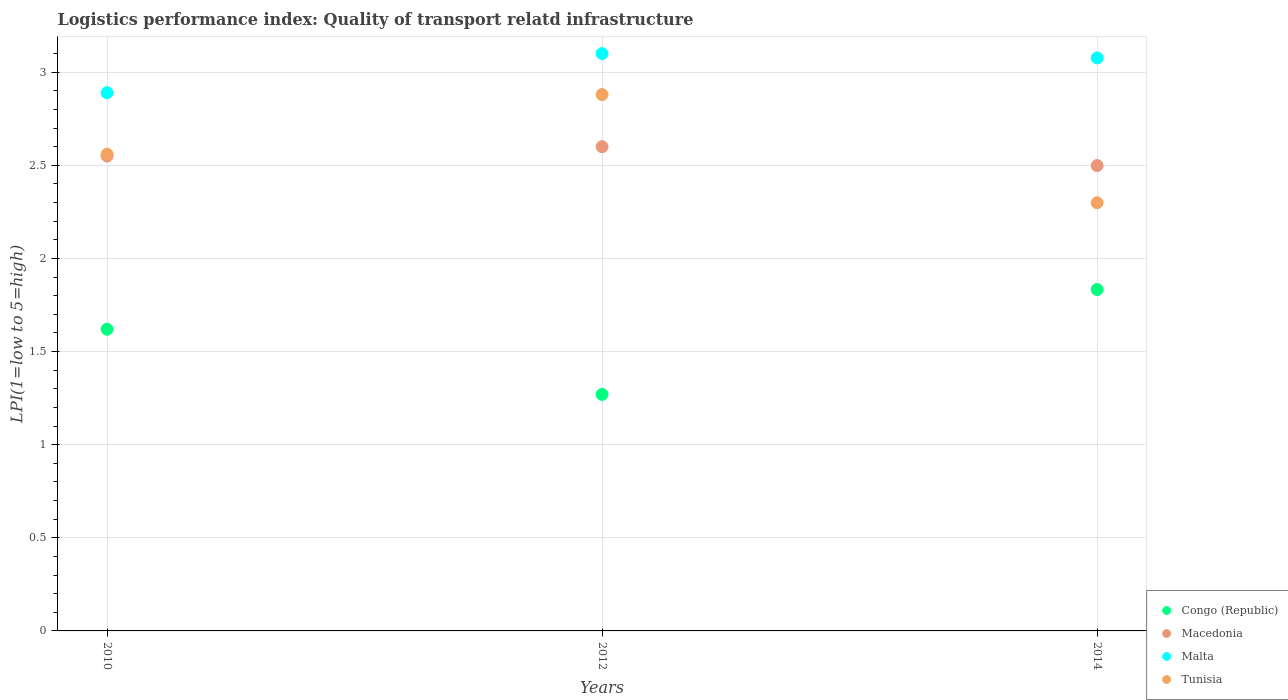What is the logistics performance index in Malta in 2012?
Ensure brevity in your answer.  3.1. Across all years, what is the maximum logistics performance index in Tunisia?
Offer a terse response. 2.88. Across all years, what is the minimum logistics performance index in Congo (Republic)?
Provide a short and direct response. 1.27. In which year was the logistics performance index in Congo (Republic) maximum?
Your answer should be very brief. 2014. What is the total logistics performance index in Tunisia in the graph?
Offer a very short reply. 7.74. What is the difference between the logistics performance index in Congo (Republic) in 2012 and that in 2014?
Give a very brief answer. -0.56. What is the difference between the logistics performance index in Tunisia in 2014 and the logistics performance index in Malta in 2010?
Provide a succinct answer. -0.59. What is the average logistics performance index in Malta per year?
Keep it short and to the point. 3.02. In the year 2010, what is the difference between the logistics performance index in Congo (Republic) and logistics performance index in Tunisia?
Your answer should be very brief. -0.94. In how many years, is the logistics performance index in Tunisia greater than 2?
Your response must be concise. 3. What is the ratio of the logistics performance index in Congo (Republic) in 2010 to that in 2014?
Offer a terse response. 0.88. What is the difference between the highest and the second highest logistics performance index in Macedonia?
Give a very brief answer. 0.05. What is the difference between the highest and the lowest logistics performance index in Congo (Republic)?
Provide a short and direct response. 0.56. Is it the case that in every year, the sum of the logistics performance index in Macedonia and logistics performance index in Tunisia  is greater than the sum of logistics performance index in Congo (Republic) and logistics performance index in Malta?
Your answer should be very brief. No. Does the logistics performance index in Macedonia monotonically increase over the years?
Provide a short and direct response. No. Is the logistics performance index in Malta strictly greater than the logistics performance index in Tunisia over the years?
Keep it short and to the point. Yes. How many dotlines are there?
Offer a terse response. 4. What is the difference between two consecutive major ticks on the Y-axis?
Keep it short and to the point. 0.5. Does the graph contain any zero values?
Provide a succinct answer. No. Does the graph contain grids?
Offer a very short reply. Yes. Where does the legend appear in the graph?
Keep it short and to the point. Bottom right. How many legend labels are there?
Your answer should be very brief. 4. How are the legend labels stacked?
Make the answer very short. Vertical. What is the title of the graph?
Provide a succinct answer. Logistics performance index: Quality of transport relatd infrastructure. Does "European Union" appear as one of the legend labels in the graph?
Provide a short and direct response. No. What is the label or title of the X-axis?
Make the answer very short. Years. What is the label or title of the Y-axis?
Your response must be concise. LPI(1=low to 5=high). What is the LPI(1=low to 5=high) in Congo (Republic) in 2010?
Your answer should be very brief. 1.62. What is the LPI(1=low to 5=high) of Macedonia in 2010?
Your answer should be very brief. 2.55. What is the LPI(1=low to 5=high) of Malta in 2010?
Ensure brevity in your answer.  2.89. What is the LPI(1=low to 5=high) in Tunisia in 2010?
Your answer should be very brief. 2.56. What is the LPI(1=low to 5=high) in Congo (Republic) in 2012?
Provide a succinct answer. 1.27. What is the LPI(1=low to 5=high) of Malta in 2012?
Make the answer very short. 3.1. What is the LPI(1=low to 5=high) in Tunisia in 2012?
Provide a short and direct response. 2.88. What is the LPI(1=low to 5=high) of Congo (Republic) in 2014?
Keep it short and to the point. 1.83. What is the LPI(1=low to 5=high) of Macedonia in 2014?
Give a very brief answer. 2.5. What is the LPI(1=low to 5=high) in Malta in 2014?
Provide a short and direct response. 3.08. What is the LPI(1=low to 5=high) of Tunisia in 2014?
Keep it short and to the point. 2.3. Across all years, what is the maximum LPI(1=low to 5=high) in Congo (Republic)?
Offer a terse response. 1.83. Across all years, what is the maximum LPI(1=low to 5=high) in Macedonia?
Offer a terse response. 2.6. Across all years, what is the maximum LPI(1=low to 5=high) in Malta?
Make the answer very short. 3.1. Across all years, what is the maximum LPI(1=low to 5=high) of Tunisia?
Ensure brevity in your answer.  2.88. Across all years, what is the minimum LPI(1=low to 5=high) of Congo (Republic)?
Make the answer very short. 1.27. Across all years, what is the minimum LPI(1=low to 5=high) of Macedonia?
Your answer should be very brief. 2.5. Across all years, what is the minimum LPI(1=low to 5=high) of Malta?
Make the answer very short. 2.89. Across all years, what is the minimum LPI(1=low to 5=high) in Tunisia?
Your response must be concise. 2.3. What is the total LPI(1=low to 5=high) of Congo (Republic) in the graph?
Your answer should be very brief. 4.72. What is the total LPI(1=low to 5=high) of Macedonia in the graph?
Ensure brevity in your answer.  7.65. What is the total LPI(1=low to 5=high) in Malta in the graph?
Ensure brevity in your answer.  9.07. What is the total LPI(1=low to 5=high) in Tunisia in the graph?
Ensure brevity in your answer.  7.74. What is the difference between the LPI(1=low to 5=high) of Congo (Republic) in 2010 and that in 2012?
Your response must be concise. 0.35. What is the difference between the LPI(1=low to 5=high) of Macedonia in 2010 and that in 2012?
Your response must be concise. -0.05. What is the difference between the LPI(1=low to 5=high) of Malta in 2010 and that in 2012?
Provide a succinct answer. -0.21. What is the difference between the LPI(1=low to 5=high) of Tunisia in 2010 and that in 2012?
Provide a succinct answer. -0.32. What is the difference between the LPI(1=low to 5=high) of Congo (Republic) in 2010 and that in 2014?
Your response must be concise. -0.21. What is the difference between the LPI(1=low to 5=high) in Macedonia in 2010 and that in 2014?
Ensure brevity in your answer.  0.05. What is the difference between the LPI(1=low to 5=high) in Malta in 2010 and that in 2014?
Provide a short and direct response. -0.19. What is the difference between the LPI(1=low to 5=high) in Tunisia in 2010 and that in 2014?
Give a very brief answer. 0.26. What is the difference between the LPI(1=low to 5=high) of Congo (Republic) in 2012 and that in 2014?
Provide a short and direct response. -0.56. What is the difference between the LPI(1=low to 5=high) in Macedonia in 2012 and that in 2014?
Make the answer very short. 0.1. What is the difference between the LPI(1=low to 5=high) in Malta in 2012 and that in 2014?
Your answer should be very brief. 0.02. What is the difference between the LPI(1=low to 5=high) of Tunisia in 2012 and that in 2014?
Provide a succinct answer. 0.58. What is the difference between the LPI(1=low to 5=high) in Congo (Republic) in 2010 and the LPI(1=low to 5=high) in Macedonia in 2012?
Provide a short and direct response. -0.98. What is the difference between the LPI(1=low to 5=high) of Congo (Republic) in 2010 and the LPI(1=low to 5=high) of Malta in 2012?
Offer a very short reply. -1.48. What is the difference between the LPI(1=low to 5=high) in Congo (Republic) in 2010 and the LPI(1=low to 5=high) in Tunisia in 2012?
Offer a very short reply. -1.26. What is the difference between the LPI(1=low to 5=high) in Macedonia in 2010 and the LPI(1=low to 5=high) in Malta in 2012?
Your answer should be compact. -0.55. What is the difference between the LPI(1=low to 5=high) of Macedonia in 2010 and the LPI(1=low to 5=high) of Tunisia in 2012?
Provide a succinct answer. -0.33. What is the difference between the LPI(1=low to 5=high) of Congo (Republic) in 2010 and the LPI(1=low to 5=high) of Macedonia in 2014?
Your response must be concise. -0.88. What is the difference between the LPI(1=low to 5=high) in Congo (Republic) in 2010 and the LPI(1=low to 5=high) in Malta in 2014?
Your answer should be compact. -1.46. What is the difference between the LPI(1=low to 5=high) in Congo (Republic) in 2010 and the LPI(1=low to 5=high) in Tunisia in 2014?
Offer a terse response. -0.68. What is the difference between the LPI(1=low to 5=high) of Macedonia in 2010 and the LPI(1=low to 5=high) of Malta in 2014?
Your answer should be very brief. -0.53. What is the difference between the LPI(1=low to 5=high) of Macedonia in 2010 and the LPI(1=low to 5=high) of Tunisia in 2014?
Keep it short and to the point. 0.25. What is the difference between the LPI(1=low to 5=high) in Malta in 2010 and the LPI(1=low to 5=high) in Tunisia in 2014?
Your response must be concise. 0.59. What is the difference between the LPI(1=low to 5=high) in Congo (Republic) in 2012 and the LPI(1=low to 5=high) in Macedonia in 2014?
Provide a succinct answer. -1.23. What is the difference between the LPI(1=low to 5=high) of Congo (Republic) in 2012 and the LPI(1=low to 5=high) of Malta in 2014?
Offer a very short reply. -1.81. What is the difference between the LPI(1=low to 5=high) in Congo (Republic) in 2012 and the LPI(1=low to 5=high) in Tunisia in 2014?
Give a very brief answer. -1.03. What is the difference between the LPI(1=low to 5=high) of Macedonia in 2012 and the LPI(1=low to 5=high) of Malta in 2014?
Your response must be concise. -0.48. What is the difference between the LPI(1=low to 5=high) of Macedonia in 2012 and the LPI(1=low to 5=high) of Tunisia in 2014?
Your answer should be very brief. 0.3. What is the difference between the LPI(1=low to 5=high) in Malta in 2012 and the LPI(1=low to 5=high) in Tunisia in 2014?
Offer a very short reply. 0.8. What is the average LPI(1=low to 5=high) of Congo (Republic) per year?
Provide a succinct answer. 1.57. What is the average LPI(1=low to 5=high) of Macedonia per year?
Your response must be concise. 2.55. What is the average LPI(1=low to 5=high) in Malta per year?
Make the answer very short. 3.02. What is the average LPI(1=low to 5=high) of Tunisia per year?
Provide a short and direct response. 2.58. In the year 2010, what is the difference between the LPI(1=low to 5=high) of Congo (Republic) and LPI(1=low to 5=high) of Macedonia?
Provide a short and direct response. -0.93. In the year 2010, what is the difference between the LPI(1=low to 5=high) in Congo (Republic) and LPI(1=low to 5=high) in Malta?
Your response must be concise. -1.27. In the year 2010, what is the difference between the LPI(1=low to 5=high) in Congo (Republic) and LPI(1=low to 5=high) in Tunisia?
Your answer should be compact. -0.94. In the year 2010, what is the difference between the LPI(1=low to 5=high) of Macedonia and LPI(1=low to 5=high) of Malta?
Keep it short and to the point. -0.34. In the year 2010, what is the difference between the LPI(1=low to 5=high) of Macedonia and LPI(1=low to 5=high) of Tunisia?
Provide a short and direct response. -0.01. In the year 2010, what is the difference between the LPI(1=low to 5=high) in Malta and LPI(1=low to 5=high) in Tunisia?
Your answer should be compact. 0.33. In the year 2012, what is the difference between the LPI(1=low to 5=high) of Congo (Republic) and LPI(1=low to 5=high) of Macedonia?
Keep it short and to the point. -1.33. In the year 2012, what is the difference between the LPI(1=low to 5=high) in Congo (Republic) and LPI(1=low to 5=high) in Malta?
Give a very brief answer. -1.83. In the year 2012, what is the difference between the LPI(1=low to 5=high) of Congo (Republic) and LPI(1=low to 5=high) of Tunisia?
Offer a very short reply. -1.61. In the year 2012, what is the difference between the LPI(1=low to 5=high) in Macedonia and LPI(1=low to 5=high) in Tunisia?
Keep it short and to the point. -0.28. In the year 2012, what is the difference between the LPI(1=low to 5=high) of Malta and LPI(1=low to 5=high) of Tunisia?
Offer a very short reply. 0.22. In the year 2014, what is the difference between the LPI(1=low to 5=high) of Congo (Republic) and LPI(1=low to 5=high) of Macedonia?
Offer a terse response. -0.67. In the year 2014, what is the difference between the LPI(1=low to 5=high) of Congo (Republic) and LPI(1=low to 5=high) of Malta?
Provide a succinct answer. -1.24. In the year 2014, what is the difference between the LPI(1=low to 5=high) in Congo (Republic) and LPI(1=low to 5=high) in Tunisia?
Provide a short and direct response. -0.47. In the year 2014, what is the difference between the LPI(1=low to 5=high) of Macedonia and LPI(1=low to 5=high) of Malta?
Keep it short and to the point. -0.58. In the year 2014, what is the difference between the LPI(1=low to 5=high) in Macedonia and LPI(1=low to 5=high) in Tunisia?
Make the answer very short. 0.2. In the year 2014, what is the difference between the LPI(1=low to 5=high) in Malta and LPI(1=low to 5=high) in Tunisia?
Make the answer very short. 0.78. What is the ratio of the LPI(1=low to 5=high) of Congo (Republic) in 2010 to that in 2012?
Offer a terse response. 1.28. What is the ratio of the LPI(1=low to 5=high) in Macedonia in 2010 to that in 2012?
Your answer should be very brief. 0.98. What is the ratio of the LPI(1=low to 5=high) in Malta in 2010 to that in 2012?
Provide a succinct answer. 0.93. What is the ratio of the LPI(1=low to 5=high) in Tunisia in 2010 to that in 2012?
Offer a terse response. 0.89. What is the ratio of the LPI(1=low to 5=high) in Congo (Republic) in 2010 to that in 2014?
Keep it short and to the point. 0.88. What is the ratio of the LPI(1=low to 5=high) of Macedonia in 2010 to that in 2014?
Your response must be concise. 1.02. What is the ratio of the LPI(1=low to 5=high) in Malta in 2010 to that in 2014?
Provide a succinct answer. 0.94. What is the ratio of the LPI(1=low to 5=high) of Tunisia in 2010 to that in 2014?
Your response must be concise. 1.11. What is the ratio of the LPI(1=low to 5=high) of Congo (Republic) in 2012 to that in 2014?
Your answer should be very brief. 0.69. What is the ratio of the LPI(1=low to 5=high) in Macedonia in 2012 to that in 2014?
Give a very brief answer. 1.04. What is the ratio of the LPI(1=low to 5=high) of Malta in 2012 to that in 2014?
Give a very brief answer. 1.01. What is the ratio of the LPI(1=low to 5=high) of Tunisia in 2012 to that in 2014?
Give a very brief answer. 1.25. What is the difference between the highest and the second highest LPI(1=low to 5=high) in Congo (Republic)?
Ensure brevity in your answer.  0.21. What is the difference between the highest and the second highest LPI(1=low to 5=high) in Macedonia?
Ensure brevity in your answer.  0.05. What is the difference between the highest and the second highest LPI(1=low to 5=high) of Malta?
Give a very brief answer. 0.02. What is the difference between the highest and the second highest LPI(1=low to 5=high) of Tunisia?
Offer a very short reply. 0.32. What is the difference between the highest and the lowest LPI(1=low to 5=high) of Congo (Republic)?
Your answer should be compact. 0.56. What is the difference between the highest and the lowest LPI(1=low to 5=high) in Macedonia?
Make the answer very short. 0.1. What is the difference between the highest and the lowest LPI(1=low to 5=high) in Malta?
Keep it short and to the point. 0.21. What is the difference between the highest and the lowest LPI(1=low to 5=high) in Tunisia?
Ensure brevity in your answer.  0.58. 